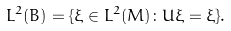Convert formula to latex. <formula><loc_0><loc_0><loc_500><loc_500>L ^ { 2 } ( B ) = \{ \xi \in L ^ { 2 } ( M ) \colon U \xi = \xi \} .</formula> 